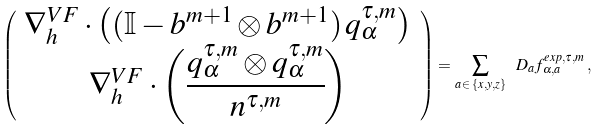<formula> <loc_0><loc_0><loc_500><loc_500>\left ( \begin{array} { c } \nabla _ { h } ^ { V F } \cdot \left ( ( \mathbb { I } - b ^ { m + 1 } \otimes b ^ { m + 1 } ) \, q _ { \alpha } ^ { \tau , m } \right ) \\ \nabla _ { h } ^ { V F } \cdot \left ( \cfrac { q _ { \alpha } ^ { \tau , m } \otimes q _ { \alpha } ^ { \tau , m } } { n ^ { \tau , m } } \right ) \end{array} \right ) = \sum _ { a \, \in \, \{ x , y , z \} } \ D _ { a } f _ { \alpha , a } ^ { e x p , \tau , m } \, ,</formula> 